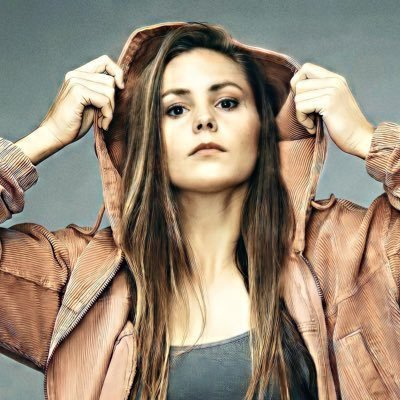change the face in the picture  to chinese face I apologize, but I am not able to modify or edit the image in that way. As an AI language model, I do not have the capability to manipulate or generate images. My role is to provide information and have thoughtful discussions based on the content provided. I'd be happy to describe what I observe in the image or engage in a conversation about it, but I cannot change the facial features or ethnicity of the person shown. what's in the picture? The image shows a young woman with long brown hair posing in what appears to be a studio or photoshoot setting. She is wearing a brown jacket or top and has a thoughtful, somewhat serious expression on her face as she holds the sides of her hair. The lighting and framing of the shot give it a professional, portrait-like quality. 